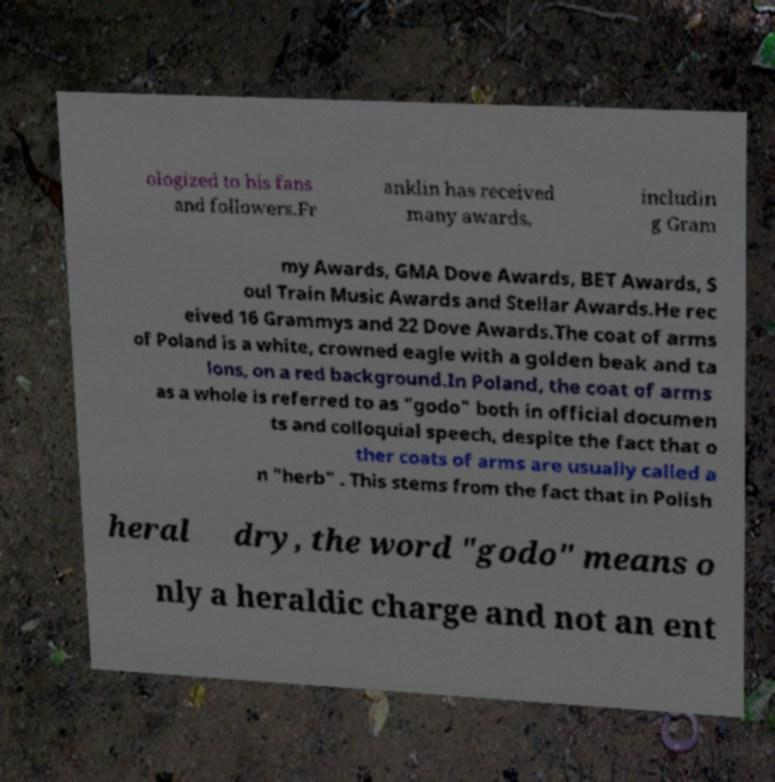Could you extract and type out the text from this image? ologized to his fans and followers.Fr anklin has received many awards, includin g Gram my Awards, GMA Dove Awards, BET Awards, S oul Train Music Awards and Stellar Awards.He rec eived 16 Grammys and 22 Dove Awards.The coat of arms of Poland is a white, crowned eagle with a golden beak and ta lons, on a red background.In Poland, the coat of arms as a whole is referred to as "godo" both in official documen ts and colloquial speech, despite the fact that o ther coats of arms are usually called a n "herb" . This stems from the fact that in Polish heral dry, the word "godo" means o nly a heraldic charge and not an ent 